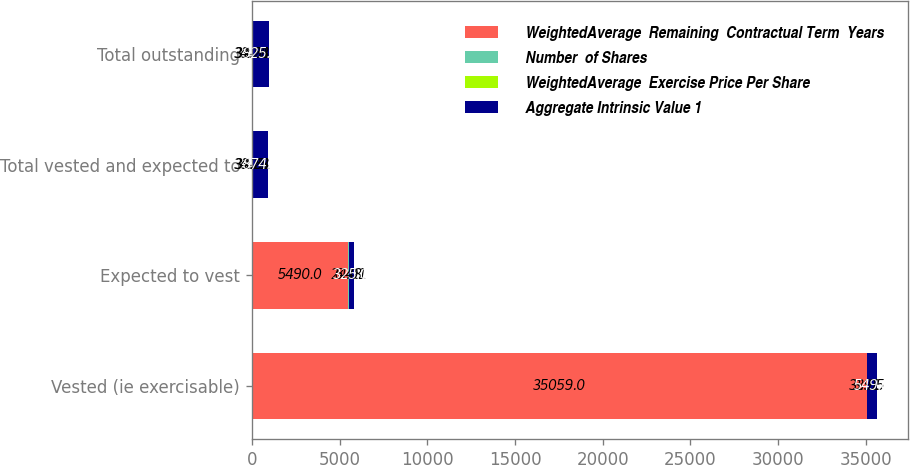Convert chart to OTSL. <chart><loc_0><loc_0><loc_500><loc_500><stacked_bar_chart><ecel><fcel>Vested (ie exercisable)<fcel>Expected to vest<fcel>Total vested and expected to<fcel>Total outstanding<nl><fcel>WeightedAverage  Remaining  Contractual Term  Years<fcel>35059<fcel>5490<fcel>33.28<fcel>33.28<nl><fcel>Number  of Shares<fcel>33.95<fcel>24.01<fcel>32.61<fcel>32.51<nl><fcel>WeightedAverage  Exercise Price Per Share<fcel>3.91<fcel>6.48<fcel>4.25<fcel>4.28<nl><fcel>Aggregate Intrinsic Value 1<fcel>549<fcel>325<fcel>874<fcel>925<nl></chart> 